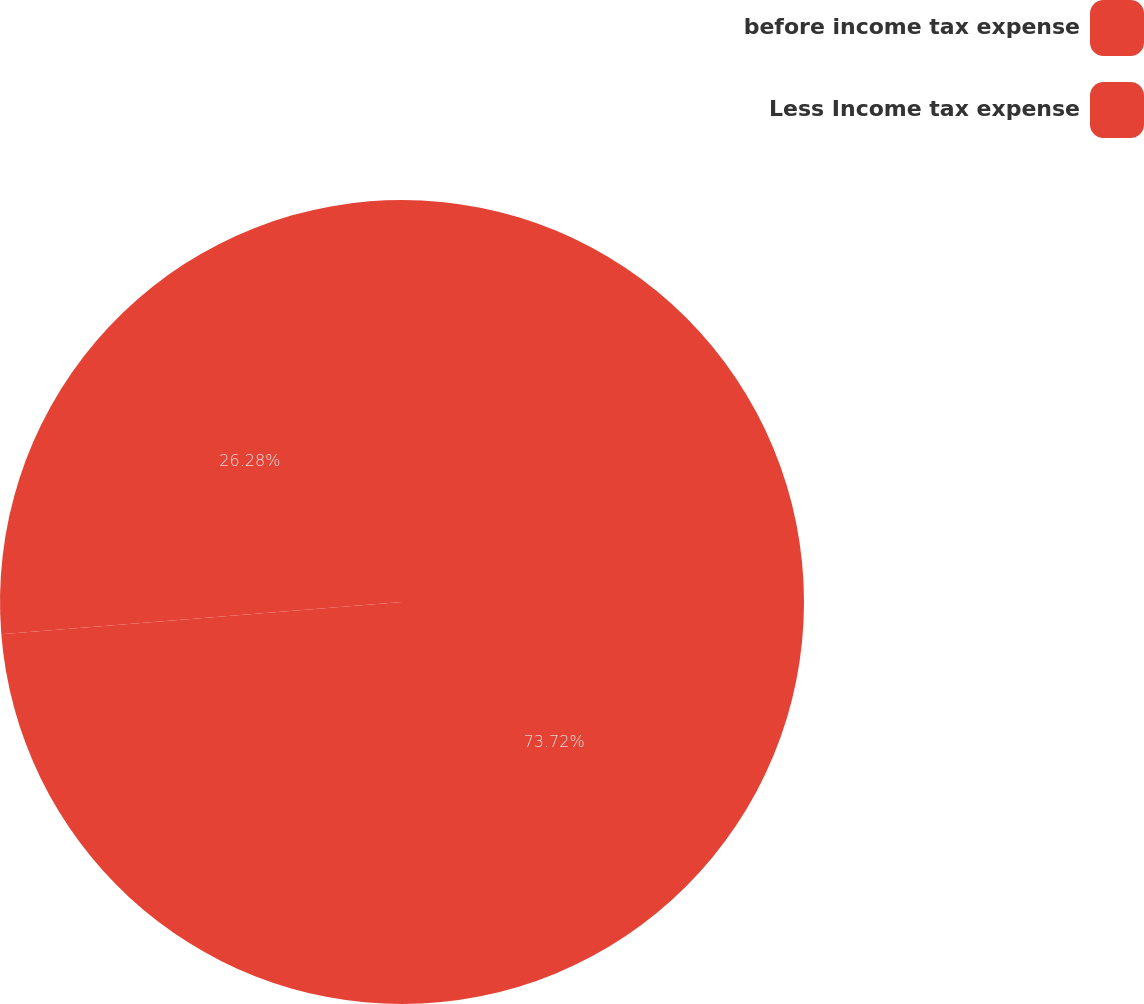<chart> <loc_0><loc_0><loc_500><loc_500><pie_chart><fcel>before income tax expense<fcel>Less Income tax expense<nl><fcel>73.72%<fcel>26.28%<nl></chart> 